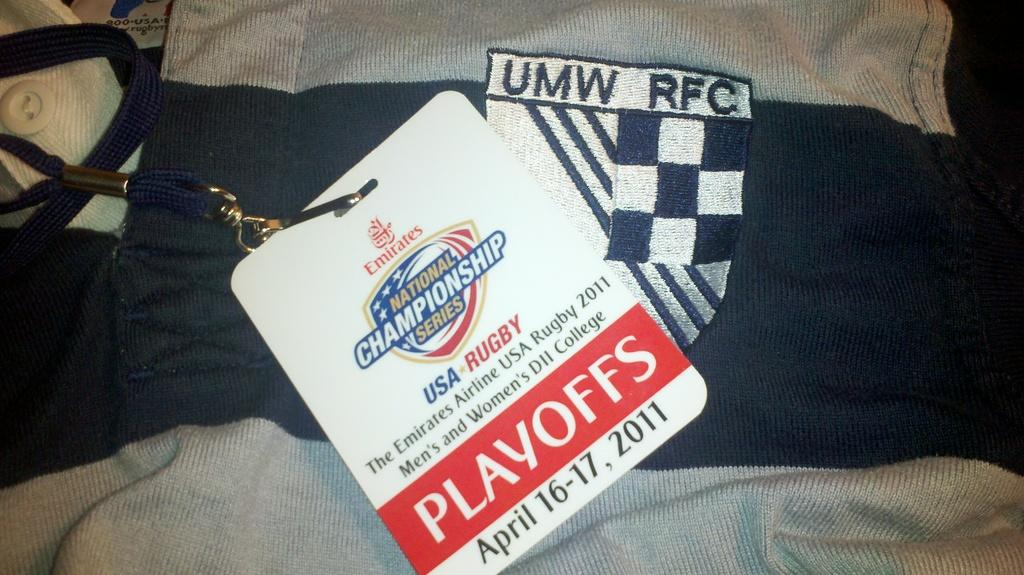What type of items can be seen in the image? There are clothes in the image. Can you identify any specific features on the clothes? Yes, there is a button and a tag in the image. What type of substance is visible in the pocket of the clothes in the image? There is no pocket visible in the image, and therefore no substance can be seen inside it. 